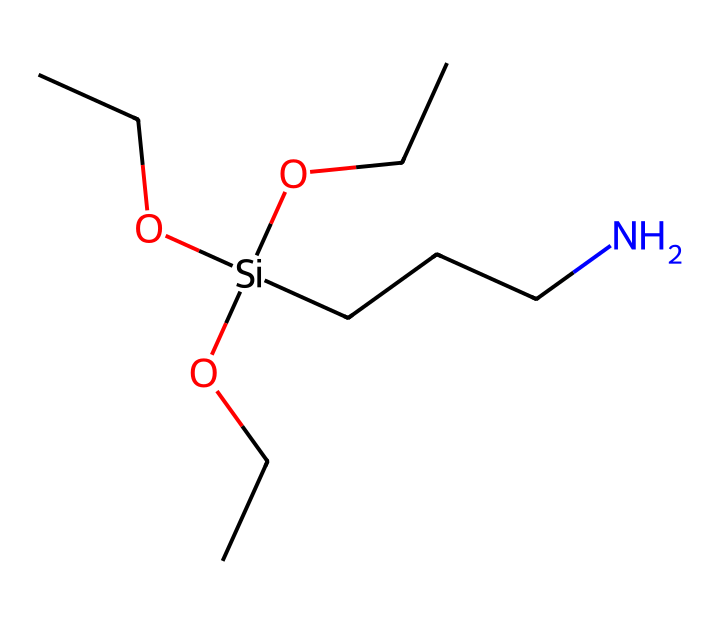what type of chemical is represented by this structure? This structure contains silicon, carbon, and oxygen atoms, indicating that it is an organosilicon compound, specifically a silane coupling agent due to its reactivity with organic materials.
Answer: organosilicon compound how many carbon atoms are present in this molecule? By analyzing the SMILES, there are five carbon atoms, indicated by the letters 'C' in the structure (excluding silicon and oxygen).
Answer: five what functional group is indicated by 'O' in the structure? The 'O' stands for the alcohol functional group in the form of hydroxyl, indicated by the position of oxygen connected to a carbon chain.
Answer: alcohol what is the degree of branching in this compound? The presence of multiple carbon chains attached to the silicon atom indicates that this compound is highly branched. Thus, it has a high branching degree.
Answer: high how many nitrogen atoms are present in this structure? Upon inspecting the SMILES representation, there is one nitrogen atom present (indicated by 'N').
Answer: one what role do silane coupling agents play in bioplastics? Silane coupling agents enhance the compatibility between polar biopolymers and non-polar fillers or reinforcements, improving the mechanical properties and performance of bioplastics.
Answer: compatibility enhancer how does the presence of silicon influence the properties of this compound? The presence of silicon in this chemical structure provides unique properties such as increased thermal stability and hydrophobic characteristics compared to organic-only compounds.
Answer: thermal stability 